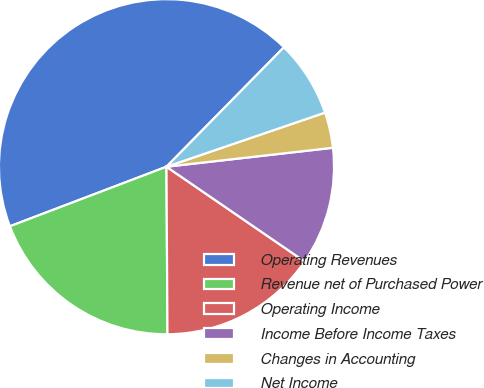<chart> <loc_0><loc_0><loc_500><loc_500><pie_chart><fcel>Operating Revenues<fcel>Revenue net of Purchased Power<fcel>Operating Income<fcel>Income Before Income Taxes<fcel>Changes in Accounting<fcel>Net Income<nl><fcel>43.15%<fcel>19.31%<fcel>15.34%<fcel>11.37%<fcel>3.43%<fcel>7.4%<nl></chart> 